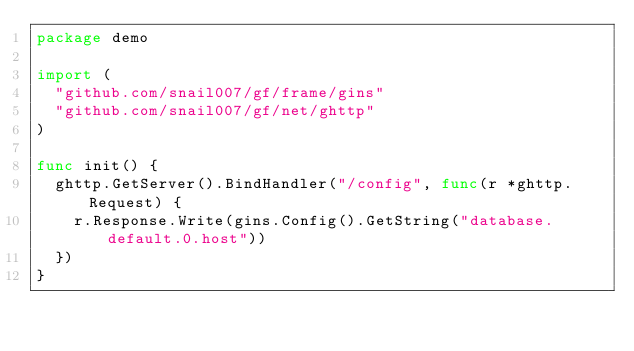<code> <loc_0><loc_0><loc_500><loc_500><_Go_>package demo

import (
	"github.com/snail007/gf/frame/gins"
	"github.com/snail007/gf/net/ghttp"
)

func init() {
	ghttp.GetServer().BindHandler("/config", func(r *ghttp.Request) {
		r.Response.Write(gins.Config().GetString("database.default.0.host"))
	})
}
</code> 